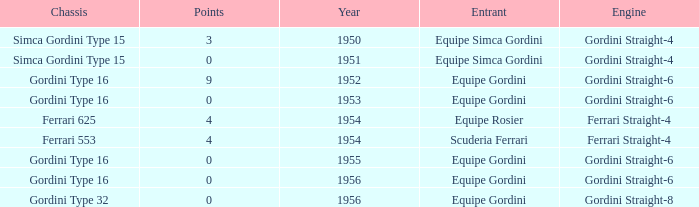What engine was used by Equipe Simca Gordini before 1956 with less than 4 points? Gordini Straight-4, Gordini Straight-4. 